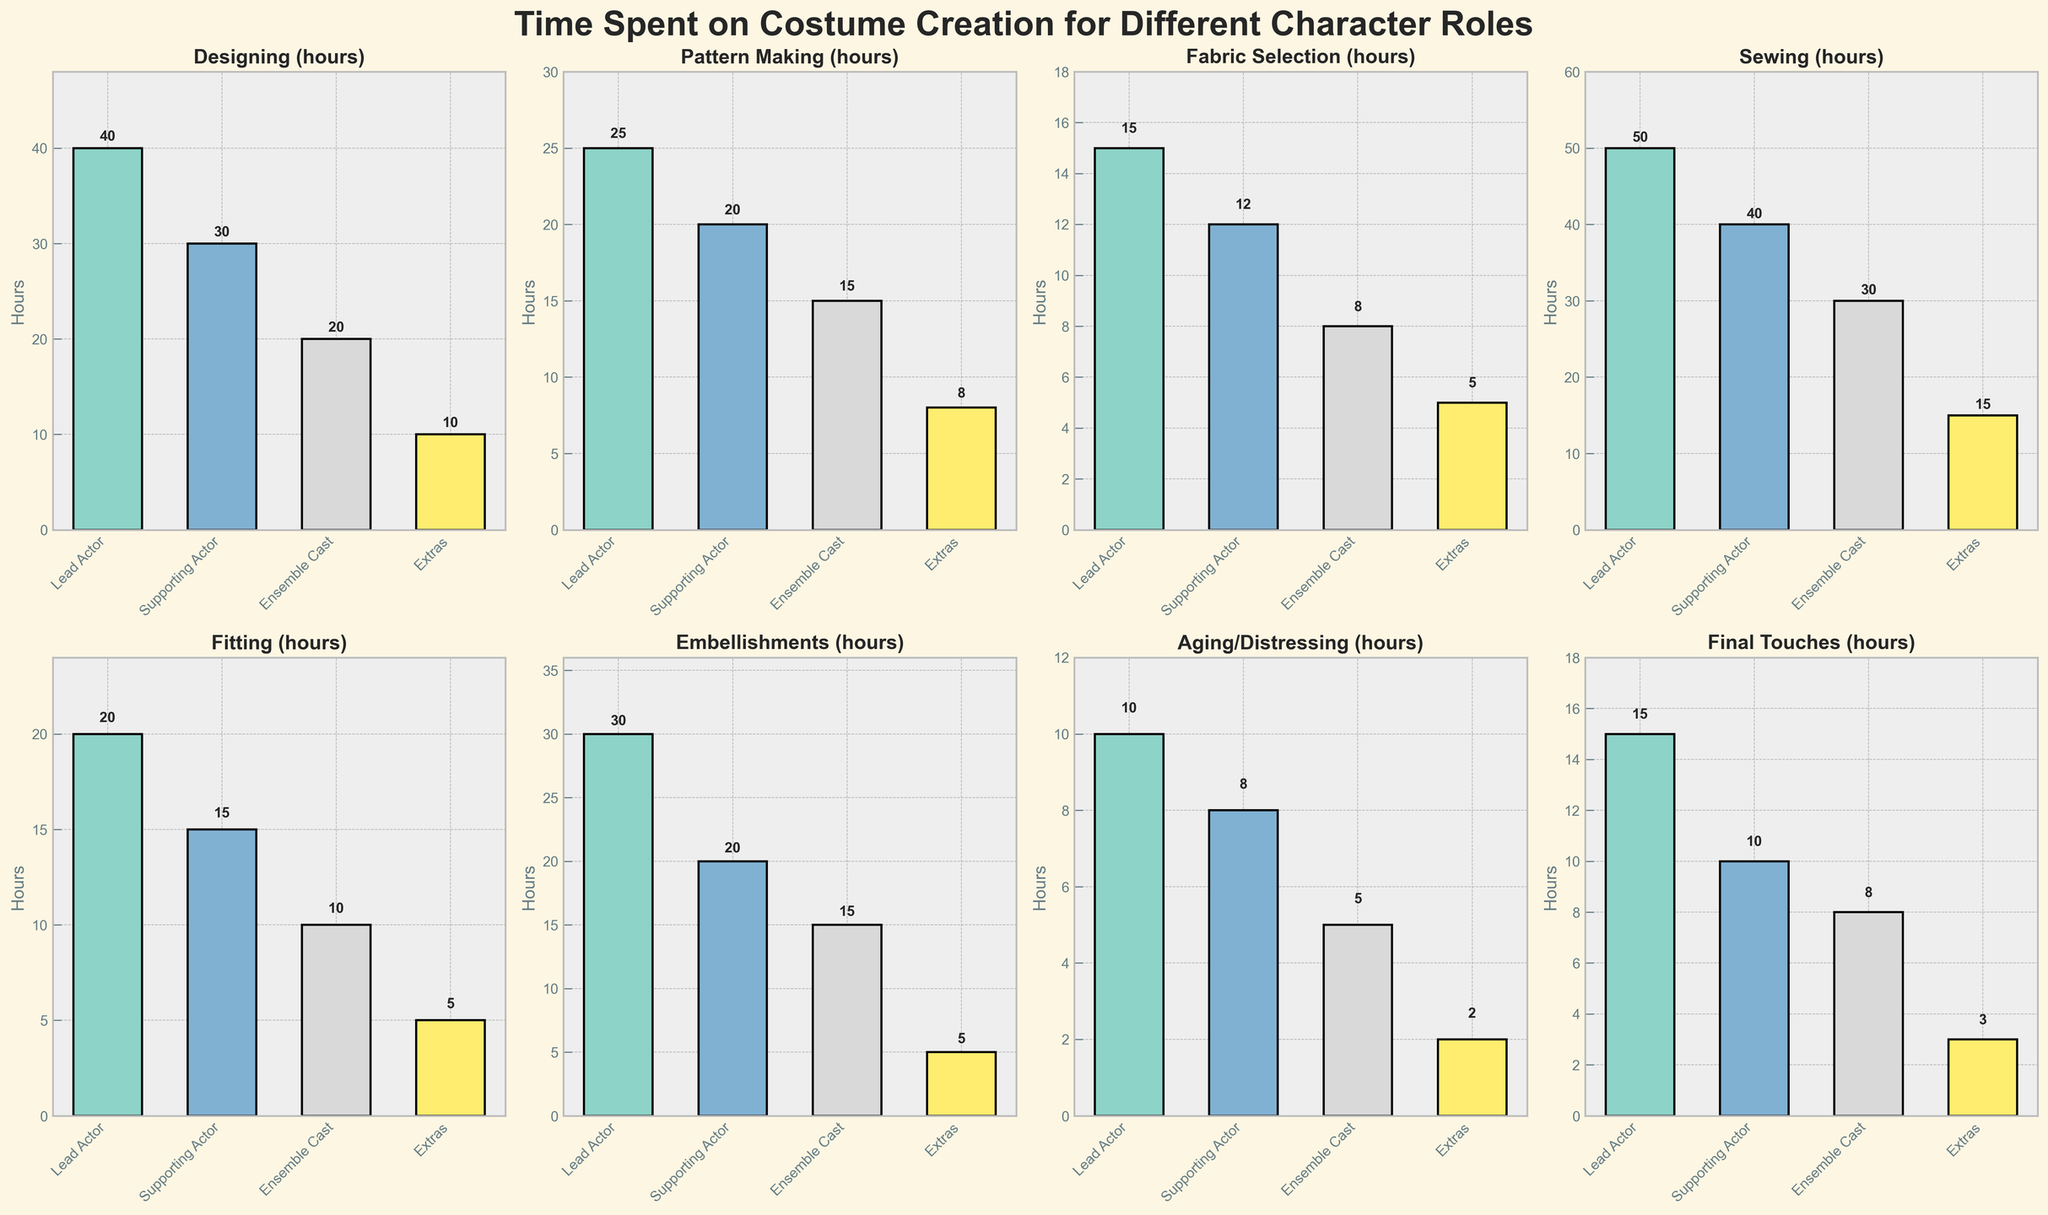What is the title of the figure? The title is usually mentioned above the plots in a larger and bold font. In this case, it reads 'Time Spent on Costume Creation for Different Character Roles'.
Answer: Time Spent on Costume Creation for Different Character Roles Which character role had the most hours spent on Sewing? The 'Sewing' subplot will show bars for different character roles. By comparing the bar heights, the lead actor role has the tallest bar for Sewing.
Answer: Lead Actor How many hours were spent designing costumes for the Supporting Actor and Ensemble Cast combined? In the 'Designing (hours)' subplot, the bars for Supporting Actor and Ensemble Cast indicate 30 and 20 hours respectively. Adding these together gives us 50 hours.
Answer: 50 hours Which task took the least amount of time for Extras? The subplot bar heights for 'Extras' across all tasks need to be compared. 'Aging/Distressing' has the shortest bar, representing 2 hours.
Answer: Aging/Distressing How do the hours spent on Embellishments for Lead Actors compare to those spent on Embellishments for Supporting Actors? In the 'Embellishments (hours)' subplot, the bars for Lead Actor and Supporting Actor indicate 30 and 20 hours respectively. Thus, Lead Actors have 10 more hours.
Answer: 10 more hours What is the average time spent on 'Final Touches' across all character roles? The 'Final Touches' subplot shows hours for Lead Actor (15), Supporting Actor (10), Ensemble Cast (8), and Extras (3). The average is calculated as (15+10+8+3)/4 = 9 hours.
Answer: 9 hours Which character role had the least hours spent on Pattern Making? The 'Pattern Making (hours)' subplot indicates the hours visually. The bar for Extras shows 8 hours, which is the shortest.
Answer: Extras What is the total time spent on Fabric Selection across all character roles? In the 'Fabric Selection (hours)' subplot, the hours for Lead Actor (15), Supporting Actor (12), Ensemble Cast (8), and Extras (5) are summed up: 15 + 12 + 8 + 5 = 40 hours.
Answer: 40 hours Which two tasks had the closest amount of time spent on Lead Actor costumes? By comparing the bar heights in all subplots for Lead Actor, 'Fabric Selection' (15 hours) and 'Final Touches' (15 hours) are the closest.
Answer: Fabric Selection and Final Touches How do the total costume creation hours for Supporting Actor compare with those for Extras? Sum up the hours for each task for both roles: Supporting Actor (30+20+12+40+15+20+8+10 = 155 hours) and Extras (10+8+5+15+5+5+2+3 = 53 hours). Supporting Actor has 102 hours more.
Answer: 102 hours more 